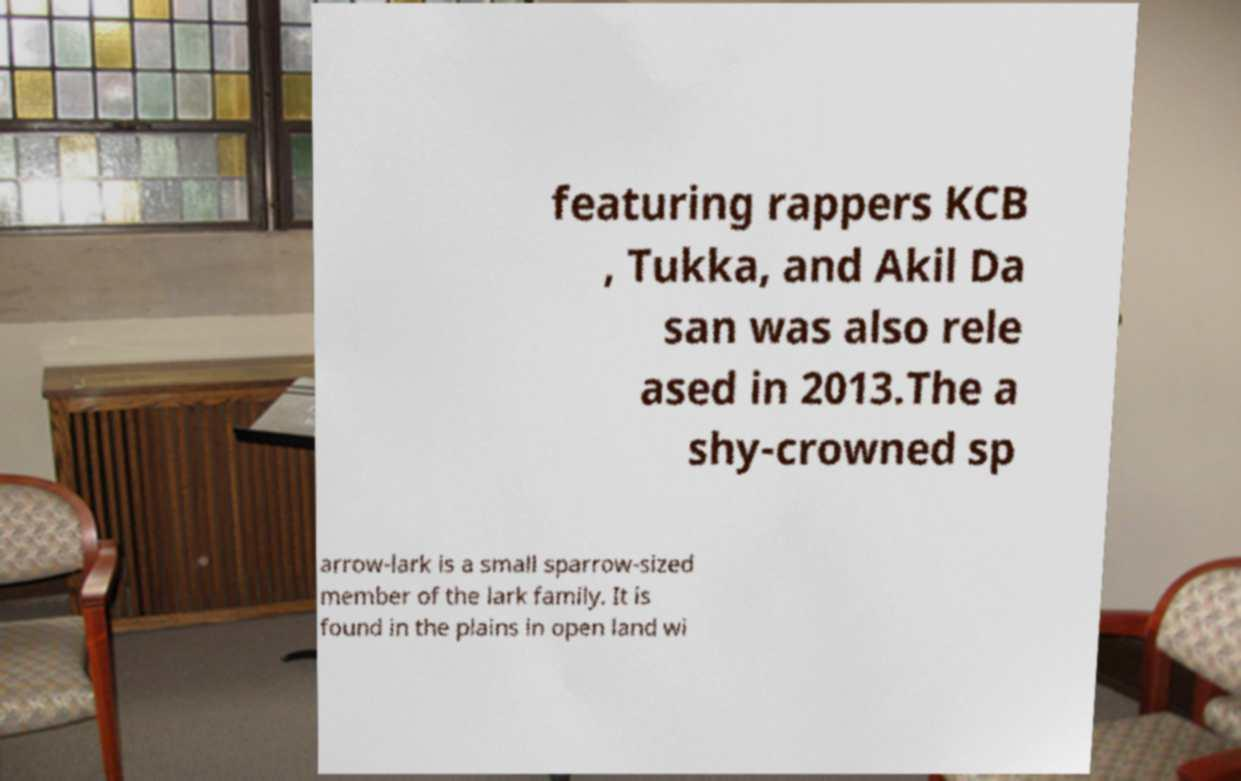Please read and relay the text visible in this image. What does it say? featuring rappers KCB , Tukka, and Akil Da san was also rele ased in 2013.The a shy-crowned sp arrow-lark is a small sparrow-sized member of the lark family. It is found in the plains in open land wi 